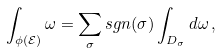Convert formula to latex. <formula><loc_0><loc_0><loc_500><loc_500>\int _ { \phi ( \mathcal { E } ) } \omega = \sum _ { \sigma } s g n ( \sigma ) \int _ { D _ { \sigma } } d \omega \, ,</formula> 